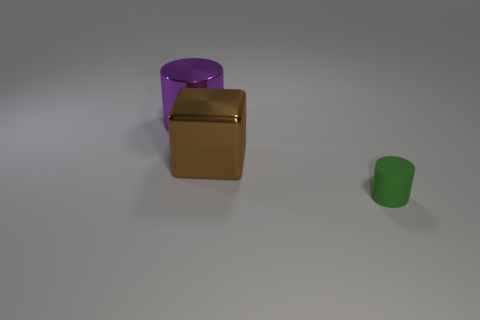There is a thing that is behind the rubber thing and in front of the large purple metallic object; what material is it?
Provide a succinct answer. Metal. Do the cylinder in front of the metallic cylinder and the metal cylinder have the same size?
Make the answer very short. No. There is a big purple metallic object; what shape is it?
Provide a succinct answer. Cylinder. What number of tiny green rubber things have the same shape as the brown metal thing?
Your response must be concise. 0. How many objects are both in front of the metal cylinder and behind the green object?
Your answer should be compact. 1. The metal cylinder is what color?
Provide a short and direct response. Purple. Are there any large purple cylinders made of the same material as the cube?
Keep it short and to the point. Yes. Are there any large purple metallic cylinders behind the big metallic thing that is in front of the cylinder that is behind the brown metal object?
Ensure brevity in your answer.  Yes. Are there any green things on the right side of the metallic cylinder?
Offer a very short reply. Yes. What number of big things are green rubber cylinders or purple rubber things?
Ensure brevity in your answer.  0. 